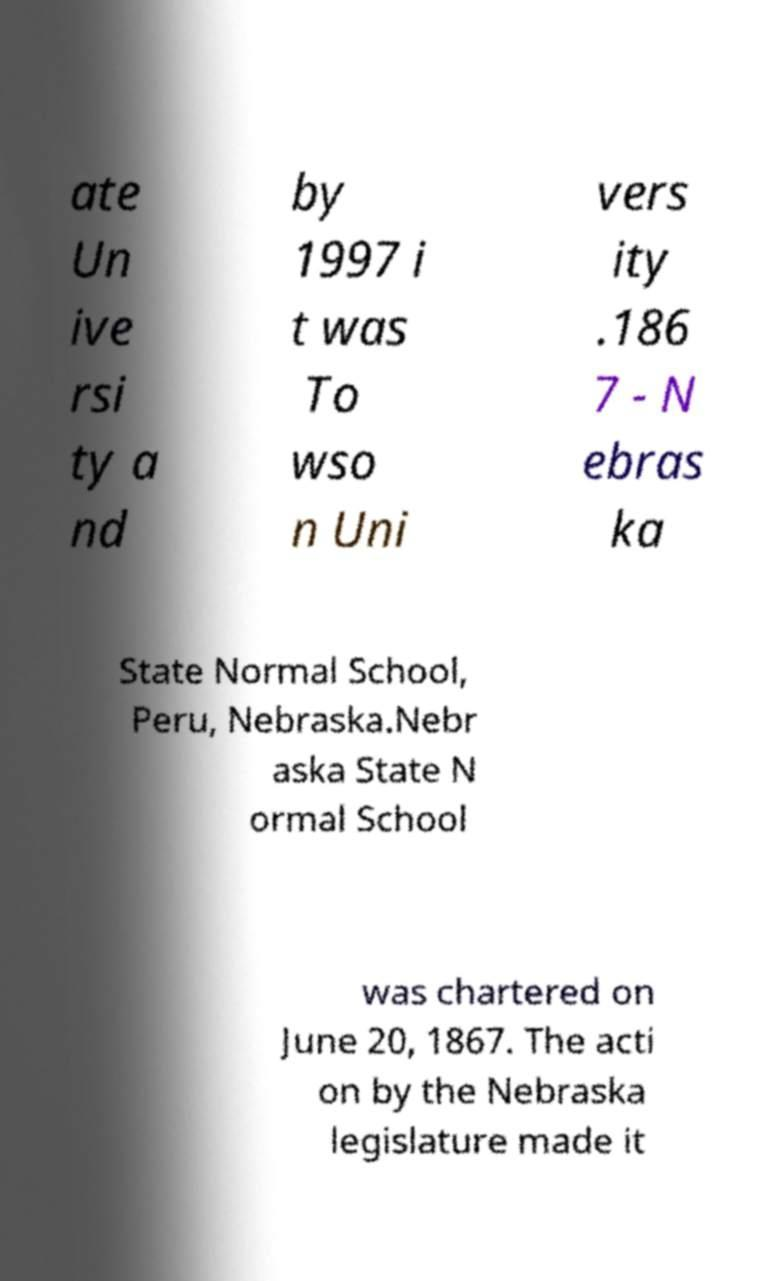Can you accurately transcribe the text from the provided image for me? ate Un ive rsi ty a nd by 1997 i t was To wso n Uni vers ity .186 7 - N ebras ka State Normal School, Peru, Nebraska.Nebr aska State N ormal School was chartered on June 20, 1867. The acti on by the Nebraska legislature made it 